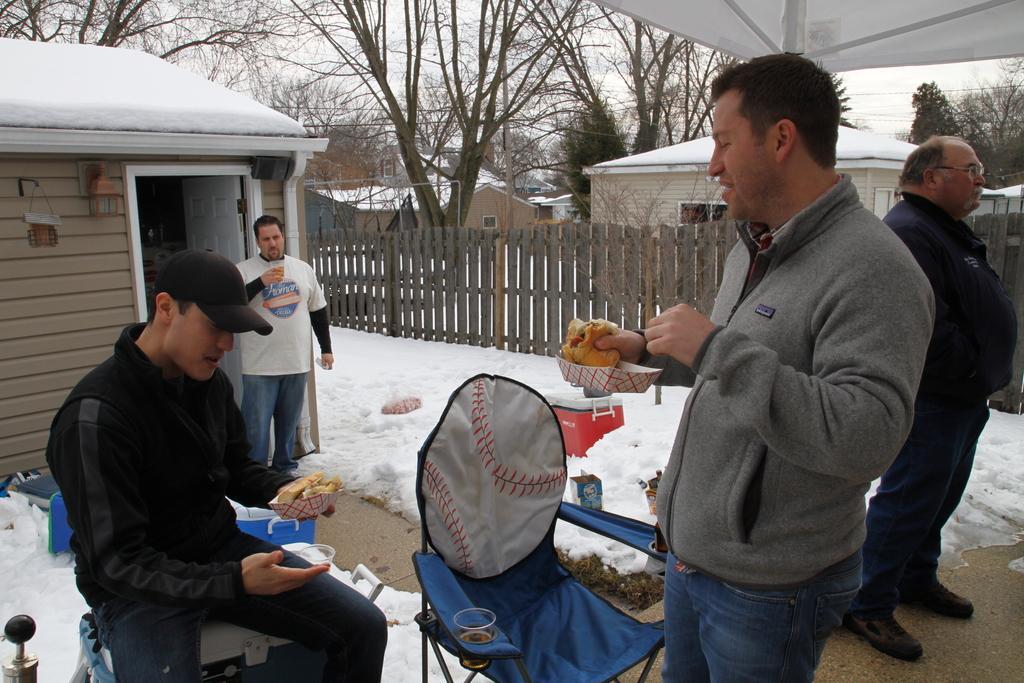In one or two sentences, can you explain what this image depicts? On the right side of the image a man is standing and another man is standing and holding a food item in his hand. On the left side of the image a man is sitting and holding a food item, other man is standing and holding a glass. In the background of the image we can see a houses, trees, fencing are there. At the bottom of the image we can see glass, boxes, chair, snow, ground are there. At the top of the image we can see tent, sky, wires are there. 